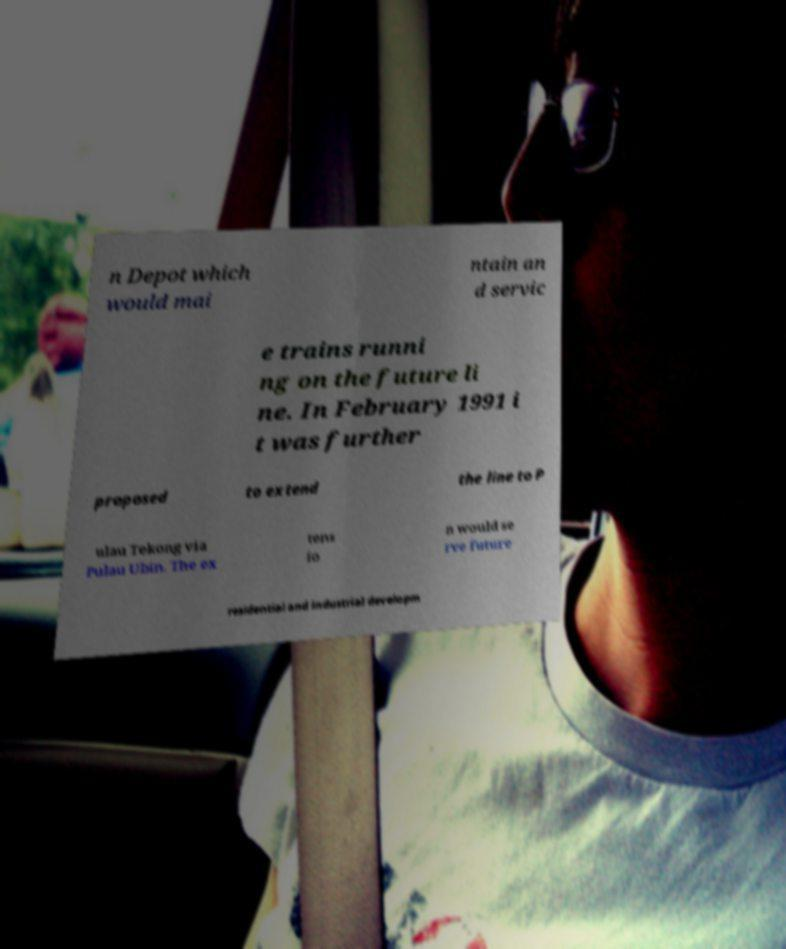Can you read and provide the text displayed in the image?This photo seems to have some interesting text. Can you extract and type it out for me? n Depot which would mai ntain an d servic e trains runni ng on the future li ne. In February 1991 i t was further proposed to extend the line to P ulau Tekong via Pulau Ubin. The ex tens io n would se rve future residential and industrial developm 